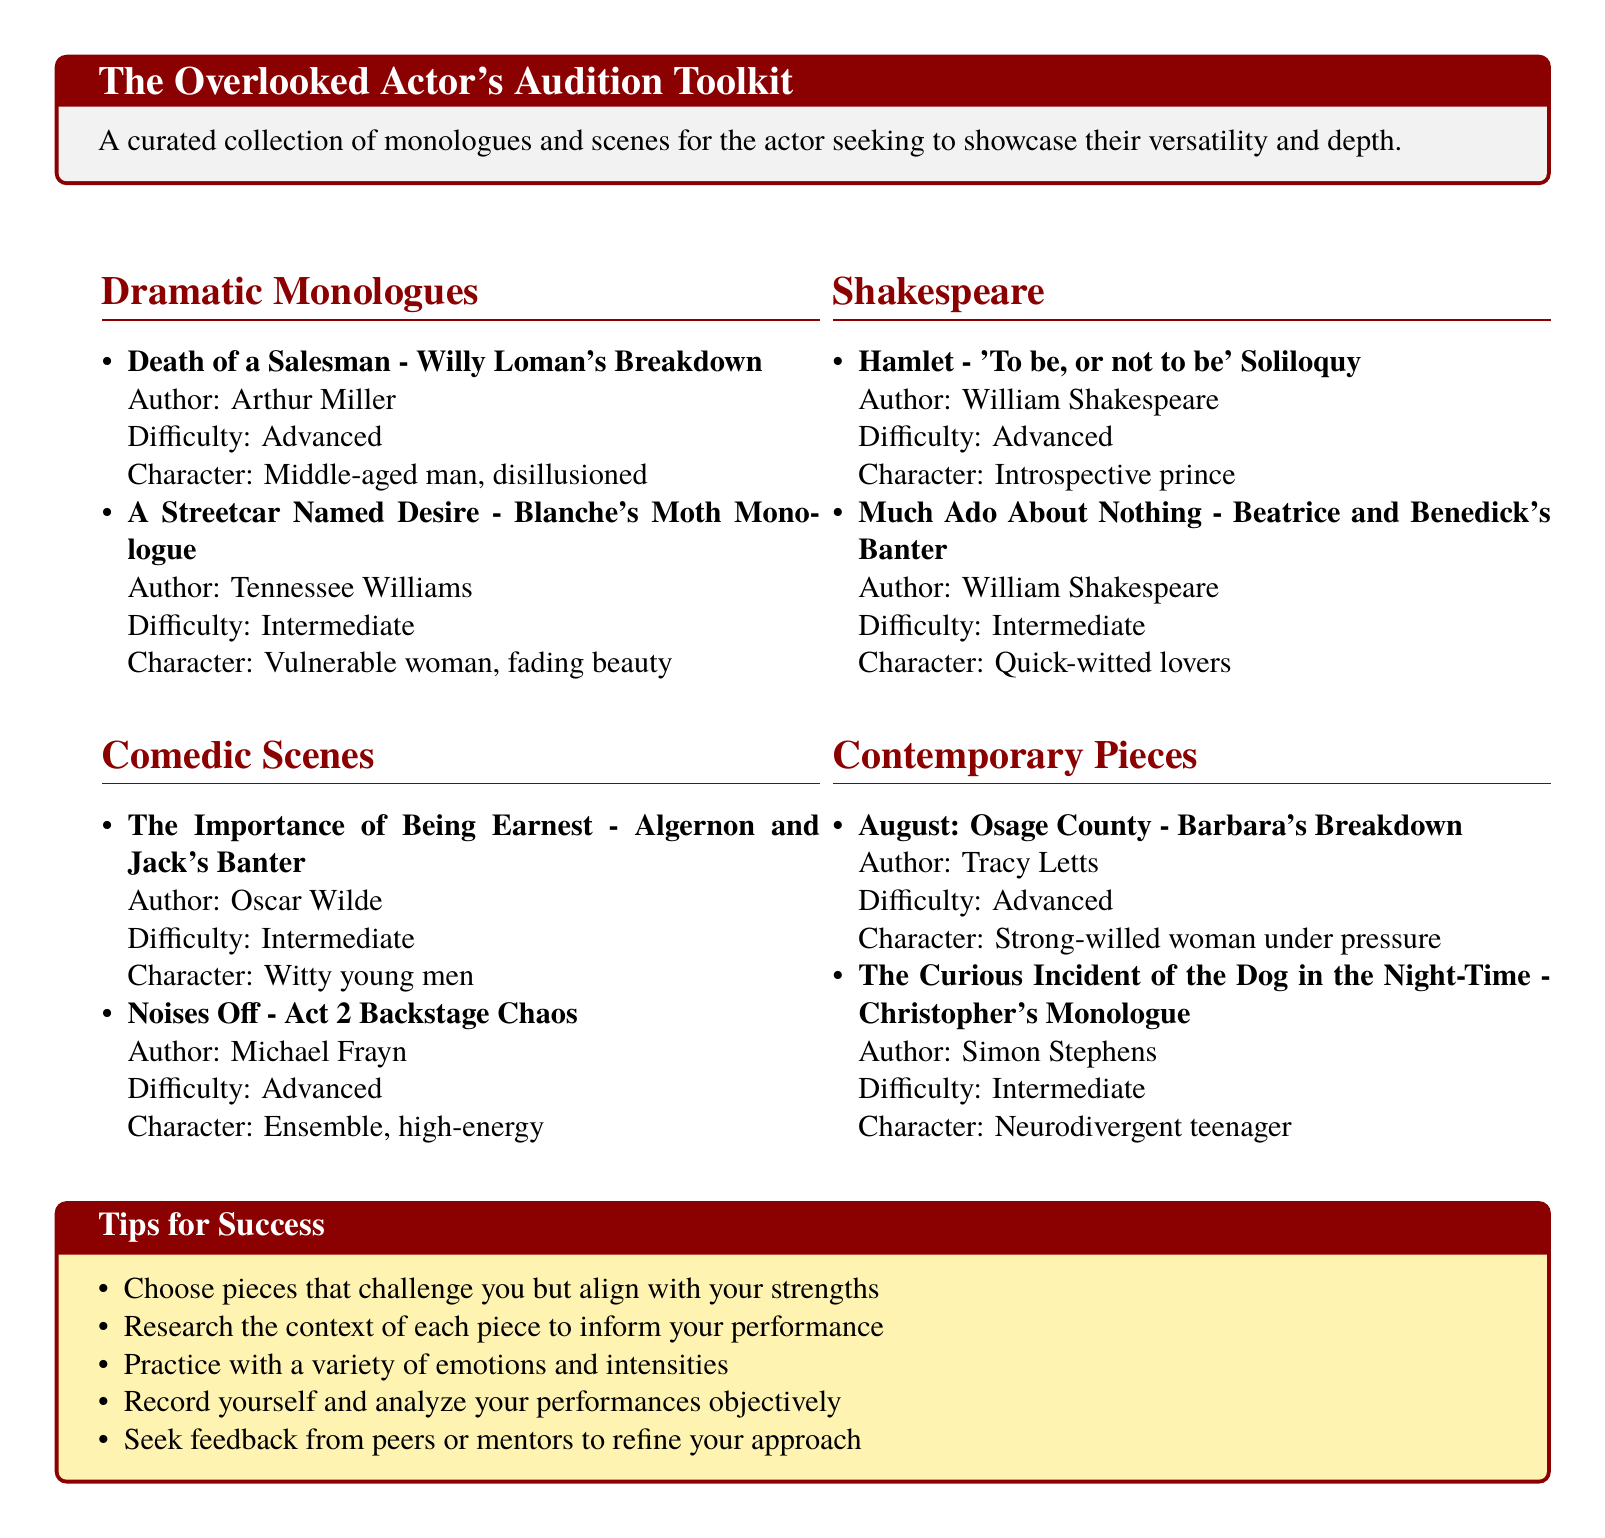What is the title of the document? The title is presented in a tcolorbox at the beginning of the document.
Answer: The Overlooked Actor's Audition Toolkit How many dramatic monologues are listed? The count can be found by counting the items in the Dramatic Monologues section.
Answer: 2 What is the character type of Blanche in A Streetcar Named Desire? The character type is specified in the description provided next to the monologue title.
Answer: Vulnerable woman, fading beauty Who is the author of the piece titled 'To be, or not to be'? The author is mentioned in the Shakespeare section next to the monologue title.
Answer: William Shakespeare What is the difficulty level of Christopher's Monologue from The Curious Incident of the Dog in the Night-Time? The difficulty level is directly stated in the description of the contemporary piece.
Answer: Intermediate How many comedic scenes are mentioned in the document? This can be determined by counting the entries in the Comedic Scenes section.
Answer: 2 What genre does the piece 'Barbara's Breakdown' belong to? The genre is identified in the header of the corresponding section.
Answer: Contemporary Which character type is associated with Willy Loman's Breakdown? The character type is specified in the details provided for the dramatic monologue.
Answer: Middle-aged man, disillusioned What is one of the tips provided for audition success? The tips are listed in a specific section aimed at aiding actors.
Answer: Choose pieces that challenge you but align with your strengths 